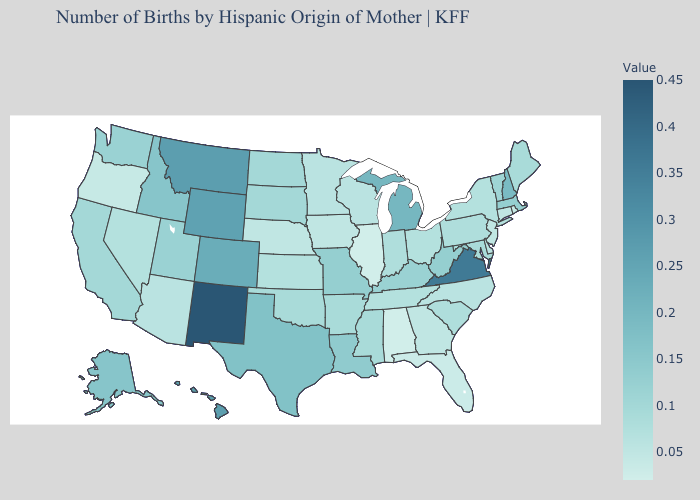Does Alabama have the lowest value in the South?
Concise answer only. Yes. Does Utah have the highest value in the West?
Short answer required. No. Which states hav the highest value in the Northeast?
Short answer required. New Hampshire. Which states hav the highest value in the West?
Give a very brief answer. New Mexico. Which states have the highest value in the USA?
Give a very brief answer. New Mexico. Does Louisiana have the highest value in the South?
Write a very short answer. No. Which states have the highest value in the USA?
Quick response, please. New Mexico. 